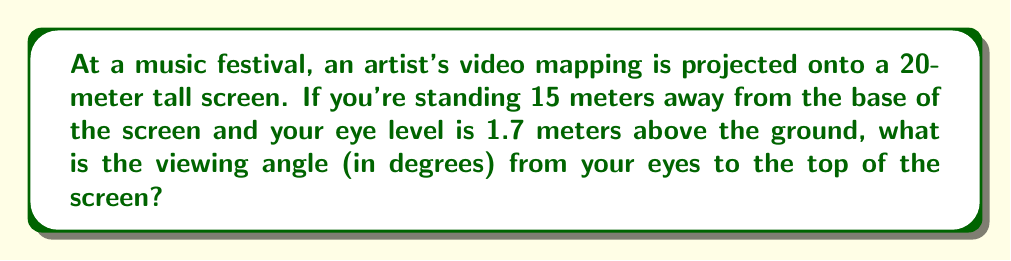Help me with this question. To solve this problem, we need to use trigonometry. Let's break it down step-by-step:

1) First, we need to identify the right triangle formed by your line of sight:
   - The base of the triangle is the horizontal distance from you to the screen (15 m)
   - The height of the triangle is the difference between the screen height and your eye level (20 m - 1.7 m = 18.3 m)

2) We can use the arctangent function to find the angle. The tangent of the angle is the opposite side divided by the adjacent side:

   $$\tan(\theta) = \frac{\text{opposite}}{\text{adjacent}} = \frac{18.3}{15}$$

3) To find the angle, we take the arctangent (inverse tangent) of this ratio:

   $$\theta = \arctan(\frac{18.3}{15})$$

4) Using a calculator or computer, we can evaluate this:

   $$\theta \approx 50.65^\circ$$

5) Round to two decimal places for the final answer.

[asy]
import geometry;

size(200);
pair A=(0,0), B=(150,0), C=(150,183);
draw(A--B--C--A);
label("15 m",B,S);
label("18.3 m",C,E);
label("$\theta$",A,NE);
dot("You",A,SW);
dot("Screen top",C,NE);
[/asy]
Answer: $50.65^\circ$ 